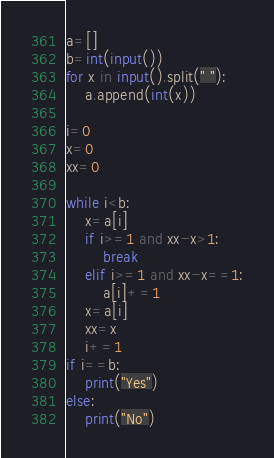<code> <loc_0><loc_0><loc_500><loc_500><_Python_>a=[]
b=int(input())
for x in input().split(" "):
    a.append(int(x))

i=0
x=0
xx=0

while i<b:
    x=a[i]
    if i>=1 and xx-x>1:
        break
    elif i>=1 and xx-x==1:
        a[i]+=1
    x=a[i]
    xx=x
    i+=1
if i==b:
    print("Yes")
else:
    print("No")</code> 